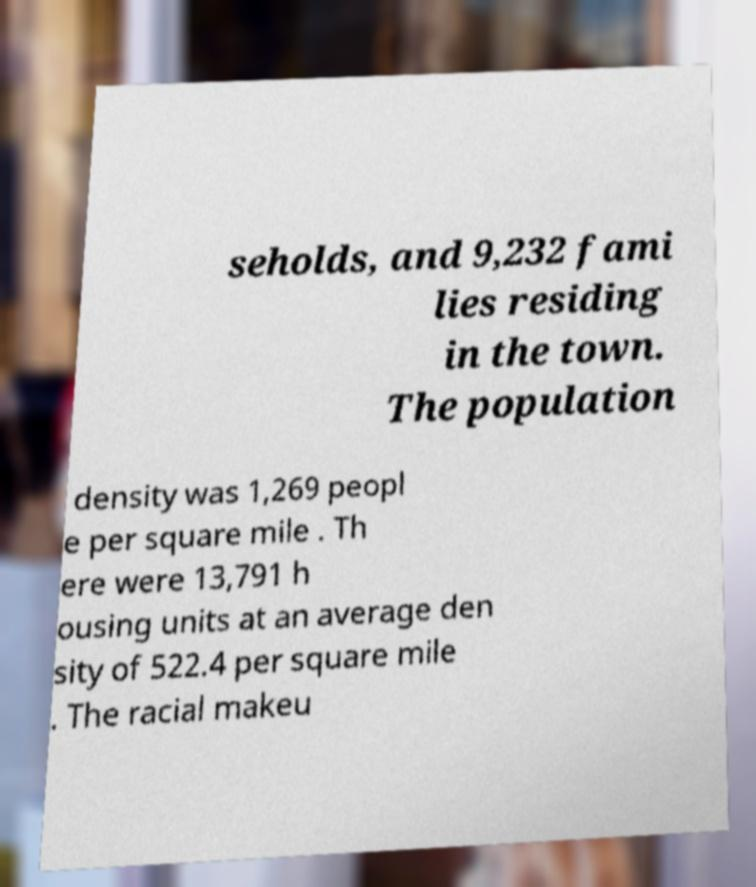Please identify and transcribe the text found in this image. seholds, and 9,232 fami lies residing in the town. The population density was 1,269 peopl e per square mile . Th ere were 13,791 h ousing units at an average den sity of 522.4 per square mile . The racial makeu 